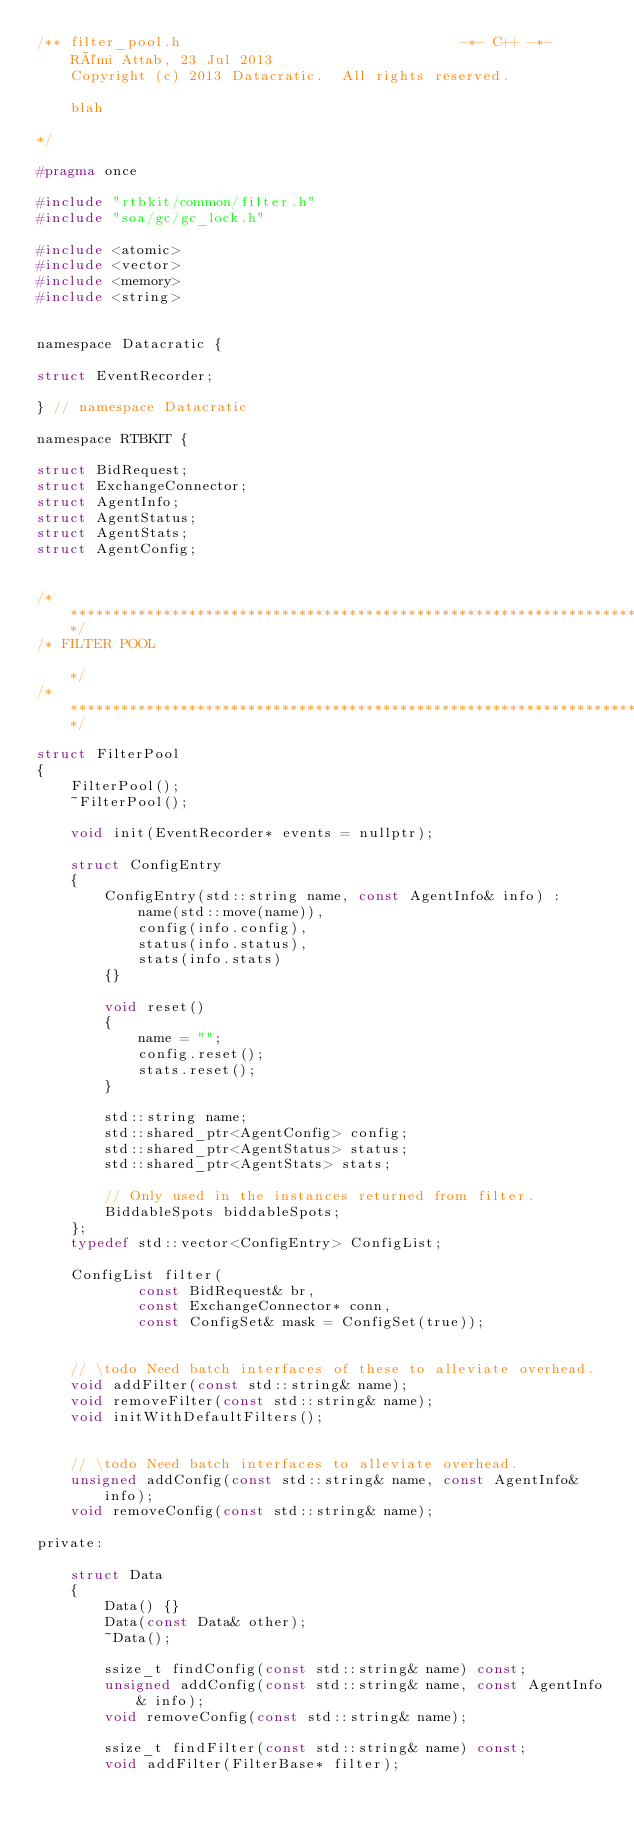<code> <loc_0><loc_0><loc_500><loc_500><_C_>/** filter_pool.h                                 -*- C++ -*-
    Rémi Attab, 23 Jul 2013
    Copyright (c) 2013 Datacratic.  All rights reserved.

    blah

*/

#pragma once

#include "rtbkit/common/filter.h"
#include "soa/gc/gc_lock.h"

#include <atomic>
#include <vector>
#include <memory>
#include <string>


namespace Datacratic {

struct EventRecorder;

} // namespace Datacratic

namespace RTBKIT {

struct BidRequest;
struct ExchangeConnector;
struct AgentInfo;
struct AgentStatus;
struct AgentStats;
struct AgentConfig;


/******************************************************************************/
/* FILTER POOL                                                                */
/******************************************************************************/

struct FilterPool
{
    FilterPool();
    ~FilterPool();

    void init(EventRecorder* events = nullptr);

    struct ConfigEntry
    {
        ConfigEntry(std::string name, const AgentInfo& info) :
            name(std::move(name)),
            config(info.config),
            status(info.status),
            stats(info.stats)
        {}

        void reset()
        {
            name = "";
            config.reset();
            stats.reset();
        }

        std::string name;
        std::shared_ptr<AgentConfig> config;
        std::shared_ptr<AgentStatus> status;
        std::shared_ptr<AgentStats> stats;

        // Only used in the instances returned from filter.
        BiddableSpots biddableSpots;
    };
    typedef std::vector<ConfigEntry> ConfigList;

    ConfigList filter(
            const BidRequest& br,
            const ExchangeConnector* conn,
            const ConfigSet& mask = ConfigSet(true));


    // \todo Need batch interfaces of these to alleviate overhead.
    void addFilter(const std::string& name);
    void removeFilter(const std::string& name);
    void initWithDefaultFilters();


    // \todo Need batch interfaces to alleviate overhead.
    unsigned addConfig(const std::string& name, const AgentInfo& info);
    void removeConfig(const std::string& name);

private:

    struct Data
    {
        Data() {}
        Data(const Data& other);
        ~Data();

        ssize_t findConfig(const std::string& name) const;
        unsigned addConfig(const std::string& name, const AgentInfo& info);
        void removeConfig(const std::string& name);

        ssize_t findFilter(const std::string& name) const;
        void addFilter(FilterBase* filter);</code> 